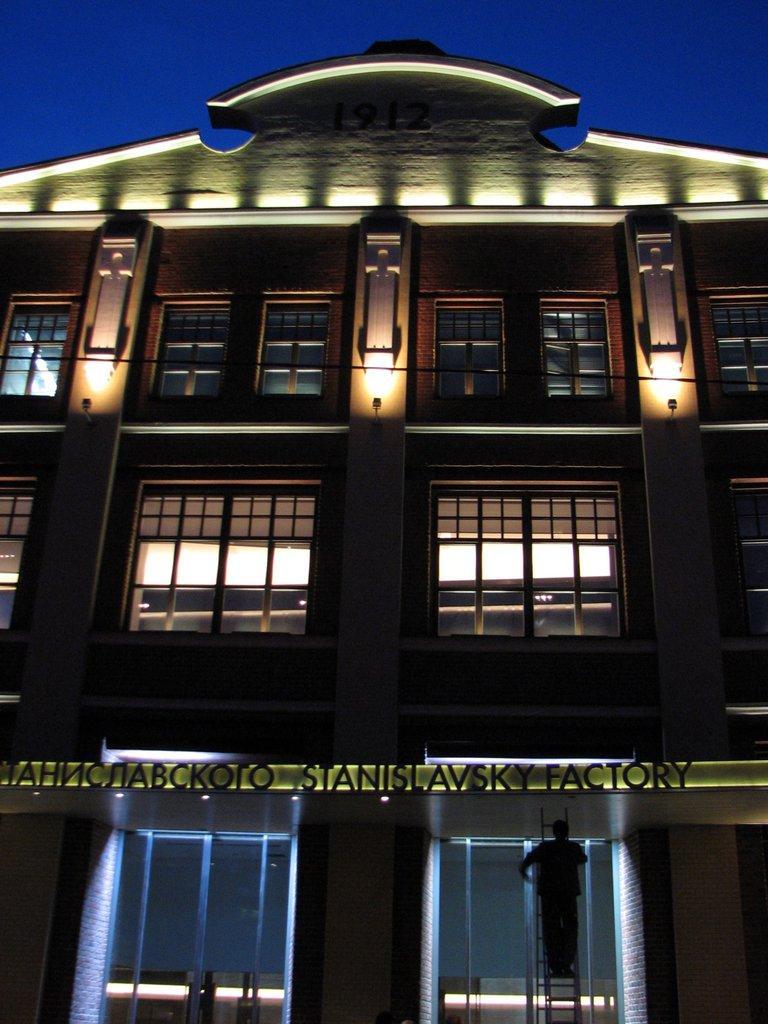How would you summarize this image in a sentence or two? In this image there is a building and on the building there is some text written on it and in front of the building there is a person climbing on the ladder and on the building there are lights, windows. 